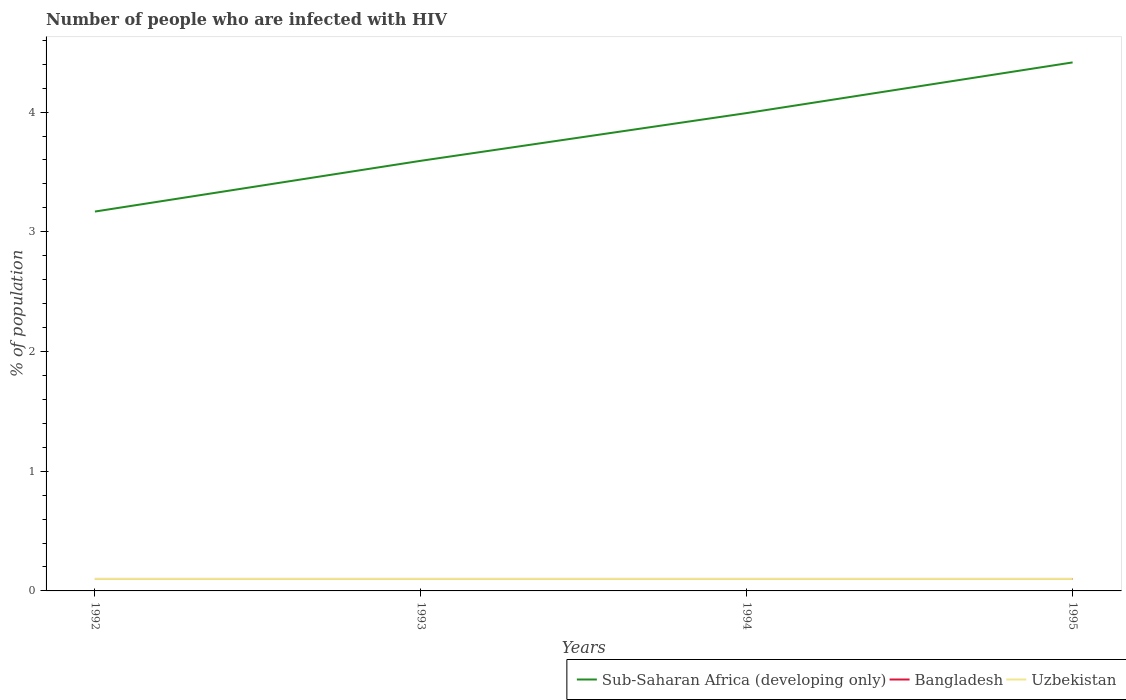Is the number of lines equal to the number of legend labels?
Provide a succinct answer. Yes. In which year was the percentage of HIV infected population in in Sub-Saharan Africa (developing only) maximum?
Your answer should be compact. 1992. What is the total percentage of HIV infected population in in Uzbekistan in the graph?
Your response must be concise. 0. What is the difference between the highest and the second highest percentage of HIV infected population in in Sub-Saharan Africa (developing only)?
Your response must be concise. 1.25. What is the difference between the highest and the lowest percentage of HIV infected population in in Uzbekistan?
Offer a terse response. 0. Is the percentage of HIV infected population in in Uzbekistan strictly greater than the percentage of HIV infected population in in Sub-Saharan Africa (developing only) over the years?
Your response must be concise. Yes. How many lines are there?
Your response must be concise. 3. What is the difference between two consecutive major ticks on the Y-axis?
Keep it short and to the point. 1. Are the values on the major ticks of Y-axis written in scientific E-notation?
Ensure brevity in your answer.  No. Does the graph contain any zero values?
Offer a terse response. No. Where does the legend appear in the graph?
Your answer should be compact. Bottom right. How are the legend labels stacked?
Give a very brief answer. Horizontal. What is the title of the graph?
Ensure brevity in your answer.  Number of people who are infected with HIV. Does "World" appear as one of the legend labels in the graph?
Give a very brief answer. No. What is the label or title of the X-axis?
Offer a very short reply. Years. What is the label or title of the Y-axis?
Make the answer very short. % of population. What is the % of population in Sub-Saharan Africa (developing only) in 1992?
Offer a terse response. 3.17. What is the % of population of Bangladesh in 1992?
Provide a succinct answer. 0.1. What is the % of population of Sub-Saharan Africa (developing only) in 1993?
Offer a very short reply. 3.59. What is the % of population in Bangladesh in 1993?
Your answer should be compact. 0.1. What is the % of population of Sub-Saharan Africa (developing only) in 1994?
Your response must be concise. 3.99. What is the % of population of Bangladesh in 1994?
Provide a succinct answer. 0.1. What is the % of population in Sub-Saharan Africa (developing only) in 1995?
Keep it short and to the point. 4.41. What is the % of population in Bangladesh in 1995?
Give a very brief answer. 0.1. What is the % of population in Uzbekistan in 1995?
Provide a succinct answer. 0.1. Across all years, what is the maximum % of population of Sub-Saharan Africa (developing only)?
Provide a succinct answer. 4.41. Across all years, what is the minimum % of population of Sub-Saharan Africa (developing only)?
Provide a succinct answer. 3.17. Across all years, what is the minimum % of population of Bangladesh?
Your answer should be compact. 0.1. What is the total % of population of Sub-Saharan Africa (developing only) in the graph?
Offer a very short reply. 15.17. What is the total % of population of Bangladesh in the graph?
Provide a succinct answer. 0.4. What is the difference between the % of population in Sub-Saharan Africa (developing only) in 1992 and that in 1993?
Offer a terse response. -0.42. What is the difference between the % of population in Bangladesh in 1992 and that in 1993?
Ensure brevity in your answer.  0. What is the difference between the % of population in Sub-Saharan Africa (developing only) in 1992 and that in 1994?
Provide a short and direct response. -0.82. What is the difference between the % of population of Bangladesh in 1992 and that in 1994?
Offer a terse response. 0. What is the difference between the % of population of Sub-Saharan Africa (developing only) in 1992 and that in 1995?
Your answer should be very brief. -1.25. What is the difference between the % of population in Sub-Saharan Africa (developing only) in 1993 and that in 1994?
Your response must be concise. -0.4. What is the difference between the % of population of Bangladesh in 1993 and that in 1994?
Provide a short and direct response. 0. What is the difference between the % of population in Uzbekistan in 1993 and that in 1994?
Make the answer very short. 0. What is the difference between the % of population of Sub-Saharan Africa (developing only) in 1993 and that in 1995?
Ensure brevity in your answer.  -0.82. What is the difference between the % of population of Sub-Saharan Africa (developing only) in 1994 and that in 1995?
Keep it short and to the point. -0.42. What is the difference between the % of population in Bangladesh in 1994 and that in 1995?
Offer a terse response. 0. What is the difference between the % of population of Uzbekistan in 1994 and that in 1995?
Ensure brevity in your answer.  0. What is the difference between the % of population in Sub-Saharan Africa (developing only) in 1992 and the % of population in Bangladesh in 1993?
Ensure brevity in your answer.  3.07. What is the difference between the % of population of Sub-Saharan Africa (developing only) in 1992 and the % of population of Uzbekistan in 1993?
Your answer should be very brief. 3.07. What is the difference between the % of population in Bangladesh in 1992 and the % of population in Uzbekistan in 1993?
Offer a terse response. 0. What is the difference between the % of population in Sub-Saharan Africa (developing only) in 1992 and the % of population in Bangladesh in 1994?
Provide a short and direct response. 3.07. What is the difference between the % of population of Sub-Saharan Africa (developing only) in 1992 and the % of population of Uzbekistan in 1994?
Your response must be concise. 3.07. What is the difference between the % of population in Sub-Saharan Africa (developing only) in 1992 and the % of population in Bangladesh in 1995?
Your response must be concise. 3.07. What is the difference between the % of population of Sub-Saharan Africa (developing only) in 1992 and the % of population of Uzbekistan in 1995?
Offer a terse response. 3.07. What is the difference between the % of population of Sub-Saharan Africa (developing only) in 1993 and the % of population of Bangladesh in 1994?
Your answer should be compact. 3.49. What is the difference between the % of population in Sub-Saharan Africa (developing only) in 1993 and the % of population in Uzbekistan in 1994?
Make the answer very short. 3.49. What is the difference between the % of population of Bangladesh in 1993 and the % of population of Uzbekistan in 1994?
Ensure brevity in your answer.  0. What is the difference between the % of population in Sub-Saharan Africa (developing only) in 1993 and the % of population in Bangladesh in 1995?
Offer a very short reply. 3.49. What is the difference between the % of population of Sub-Saharan Africa (developing only) in 1993 and the % of population of Uzbekistan in 1995?
Make the answer very short. 3.49. What is the difference between the % of population of Sub-Saharan Africa (developing only) in 1994 and the % of population of Bangladesh in 1995?
Your response must be concise. 3.89. What is the difference between the % of population of Sub-Saharan Africa (developing only) in 1994 and the % of population of Uzbekistan in 1995?
Make the answer very short. 3.89. What is the difference between the % of population in Bangladesh in 1994 and the % of population in Uzbekistan in 1995?
Offer a very short reply. 0. What is the average % of population of Sub-Saharan Africa (developing only) per year?
Give a very brief answer. 3.79. What is the average % of population of Bangladesh per year?
Offer a very short reply. 0.1. What is the average % of population in Uzbekistan per year?
Your answer should be compact. 0.1. In the year 1992, what is the difference between the % of population of Sub-Saharan Africa (developing only) and % of population of Bangladesh?
Make the answer very short. 3.07. In the year 1992, what is the difference between the % of population of Sub-Saharan Africa (developing only) and % of population of Uzbekistan?
Keep it short and to the point. 3.07. In the year 1992, what is the difference between the % of population of Bangladesh and % of population of Uzbekistan?
Your response must be concise. 0. In the year 1993, what is the difference between the % of population of Sub-Saharan Africa (developing only) and % of population of Bangladesh?
Your answer should be compact. 3.49. In the year 1993, what is the difference between the % of population of Sub-Saharan Africa (developing only) and % of population of Uzbekistan?
Make the answer very short. 3.49. In the year 1994, what is the difference between the % of population of Sub-Saharan Africa (developing only) and % of population of Bangladesh?
Provide a succinct answer. 3.89. In the year 1994, what is the difference between the % of population in Sub-Saharan Africa (developing only) and % of population in Uzbekistan?
Your response must be concise. 3.89. In the year 1994, what is the difference between the % of population of Bangladesh and % of population of Uzbekistan?
Provide a short and direct response. 0. In the year 1995, what is the difference between the % of population in Sub-Saharan Africa (developing only) and % of population in Bangladesh?
Offer a very short reply. 4.31. In the year 1995, what is the difference between the % of population in Sub-Saharan Africa (developing only) and % of population in Uzbekistan?
Give a very brief answer. 4.31. In the year 1995, what is the difference between the % of population in Bangladesh and % of population in Uzbekistan?
Ensure brevity in your answer.  0. What is the ratio of the % of population of Sub-Saharan Africa (developing only) in 1992 to that in 1993?
Keep it short and to the point. 0.88. What is the ratio of the % of population in Bangladesh in 1992 to that in 1993?
Ensure brevity in your answer.  1. What is the ratio of the % of population in Sub-Saharan Africa (developing only) in 1992 to that in 1994?
Make the answer very short. 0.79. What is the ratio of the % of population in Bangladesh in 1992 to that in 1994?
Keep it short and to the point. 1. What is the ratio of the % of population of Sub-Saharan Africa (developing only) in 1992 to that in 1995?
Your answer should be compact. 0.72. What is the ratio of the % of population in Bangladesh in 1992 to that in 1995?
Ensure brevity in your answer.  1. What is the ratio of the % of population in Uzbekistan in 1992 to that in 1995?
Provide a short and direct response. 1. What is the ratio of the % of population in Sub-Saharan Africa (developing only) in 1993 to that in 1994?
Provide a succinct answer. 0.9. What is the ratio of the % of population in Bangladesh in 1993 to that in 1994?
Ensure brevity in your answer.  1. What is the ratio of the % of population in Sub-Saharan Africa (developing only) in 1993 to that in 1995?
Provide a succinct answer. 0.81. What is the ratio of the % of population of Bangladesh in 1993 to that in 1995?
Ensure brevity in your answer.  1. What is the ratio of the % of population in Sub-Saharan Africa (developing only) in 1994 to that in 1995?
Give a very brief answer. 0.9. What is the difference between the highest and the second highest % of population in Sub-Saharan Africa (developing only)?
Provide a short and direct response. 0.42. What is the difference between the highest and the second highest % of population of Bangladesh?
Offer a terse response. 0. What is the difference between the highest and the lowest % of population in Sub-Saharan Africa (developing only)?
Provide a short and direct response. 1.25. What is the difference between the highest and the lowest % of population in Bangladesh?
Your answer should be compact. 0. 